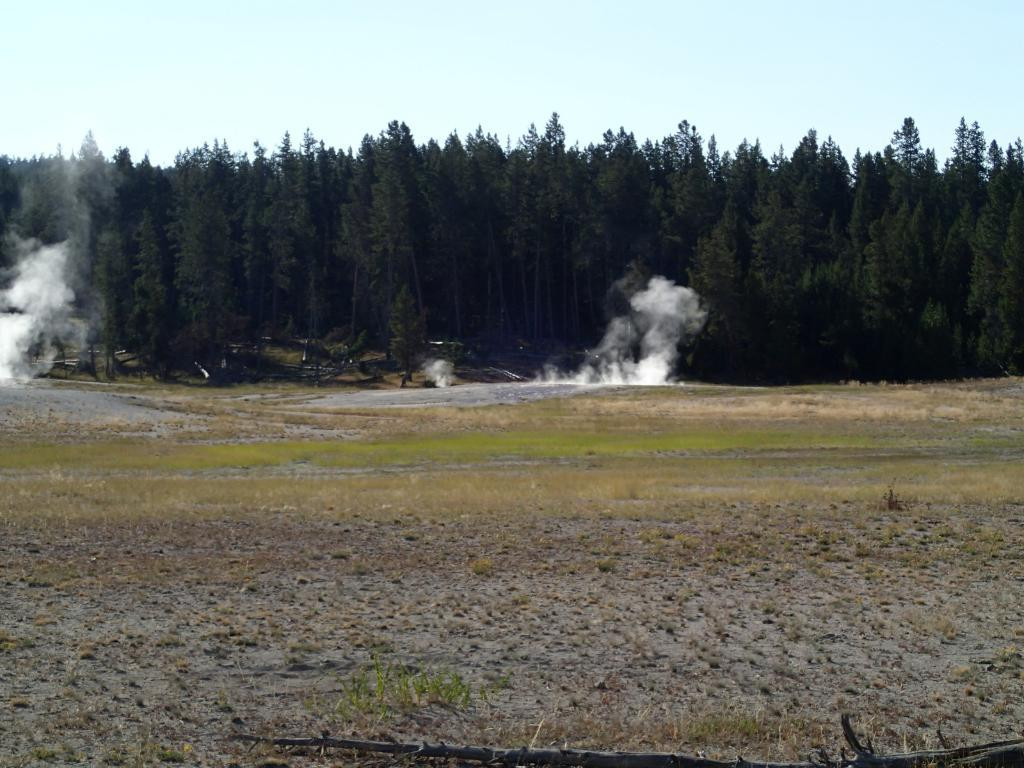What type of vegetation is on the ground in the image? There is grass on the ground in the image. What can be seen in the background of the image? There are trees in the background of the image. What is the source of the smoke visible in front of the trees? The source of the smoke is not visible in the image, but it is present in front of the trees. What is visible at the top of the image? The sky is visible at the top of the image. Can you tell me how many family members are sitting on the leaf in the image? There is no leaf or family members present in the image. Are the fairies flying around the trees in the image? There are no fairies present in the image. 